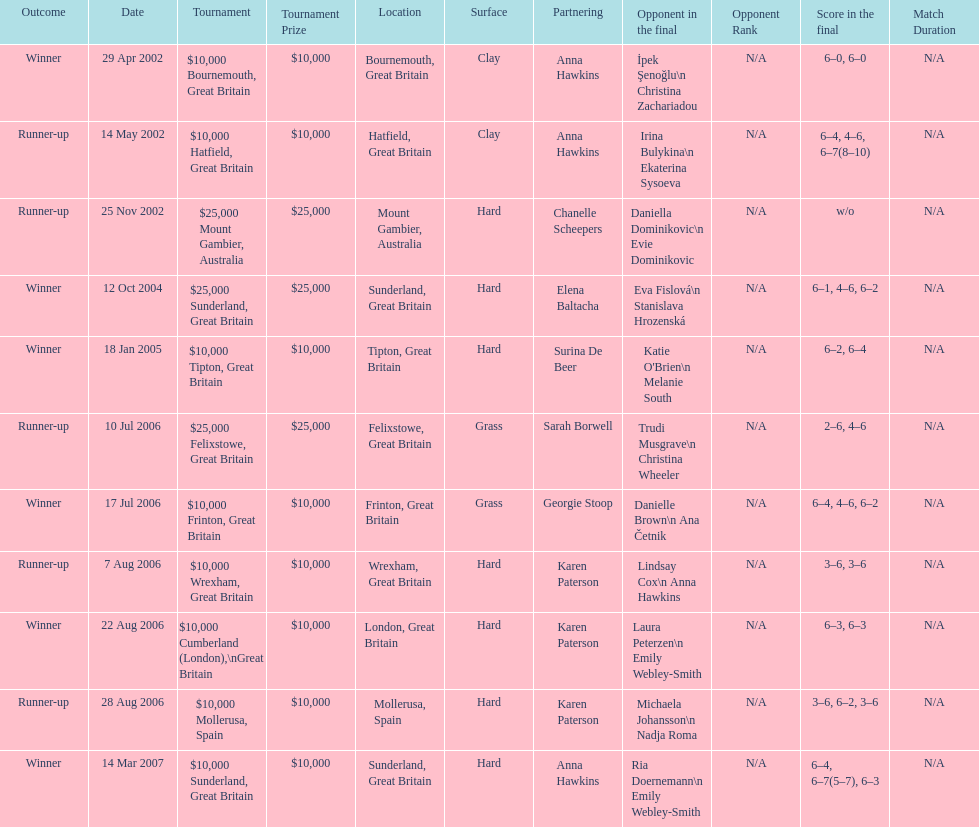Could you help me parse every detail presented in this table? {'header': ['Outcome', 'Date', 'Tournament', 'Tournament Prize', 'Location', 'Surface', 'Partnering', 'Opponent in the final', 'Opponent Rank', 'Score in the final', 'Match Duration'], 'rows': [['Winner', '29 Apr 2002', '$10,000 Bournemouth, Great Britain', '$10,000', 'Bournemouth, Great Britain', 'Clay', 'Anna Hawkins', 'İpek Şenoğlu\\n Christina Zachariadou', 'N/A', '6–0, 6–0', 'N/A'], ['Runner-up', '14 May 2002', '$10,000 Hatfield, Great Britain', '$10,000', 'Hatfield, Great Britain', 'Clay', 'Anna Hawkins', 'Irina Bulykina\\n Ekaterina Sysoeva', 'N/A', '6–4, 4–6, 6–7(8–10)', 'N/A'], ['Runner-up', '25 Nov 2002', '$25,000 Mount Gambier, Australia', '$25,000', 'Mount Gambier, Australia', 'Hard', 'Chanelle Scheepers', 'Daniella Dominikovic\\n Evie Dominikovic', 'N/A', 'w/o', 'N/A'], ['Winner', '12 Oct 2004', '$25,000 Sunderland, Great Britain', '$25,000', 'Sunderland, Great Britain', 'Hard', 'Elena Baltacha', 'Eva Fislová\\n Stanislava Hrozenská', 'N/A', '6–1, 4–6, 6–2', 'N/A'], ['Winner', '18 Jan 2005', '$10,000 Tipton, Great Britain', '$10,000', 'Tipton, Great Britain', 'Hard', 'Surina De Beer', "Katie O'Brien\\n Melanie South", 'N/A', '6–2, 6–4', 'N/A'], ['Runner-up', '10 Jul 2006', '$25,000 Felixstowe, Great Britain', '$25,000', 'Felixstowe, Great Britain', 'Grass', 'Sarah Borwell', 'Trudi Musgrave\\n Christina Wheeler', 'N/A', '2–6, 4–6', 'N/A'], ['Winner', '17 Jul 2006', '$10,000 Frinton, Great Britain', '$10,000', 'Frinton, Great Britain', 'Grass', 'Georgie Stoop', 'Danielle Brown\\n Ana Četnik', 'N/A', '6–4, 4–6, 6–2', 'N/A'], ['Runner-up', '7 Aug 2006', '$10,000 Wrexham, Great Britain', '$10,000', 'Wrexham, Great Britain', 'Hard', 'Karen Paterson', 'Lindsay Cox\\n Anna Hawkins', 'N/A', '3–6, 3–6', 'N/A'], ['Winner', '22 Aug 2006', '$10,000 Cumberland (London),\\nGreat Britain', '$10,000', 'London, Great Britain', 'Hard', 'Karen Paterson', 'Laura Peterzen\\n Emily Webley-Smith', 'N/A', '6–3, 6–3', 'N/A'], ['Runner-up', '28 Aug 2006', '$10,000 Mollerusa, Spain', '$10,000', 'Mollerusa, Spain', 'Hard', 'Karen Paterson', 'Michaela Johansson\\n Nadja Roma', 'N/A', '3–6, 6–2, 3–6', 'N/A'], ['Winner', '14 Mar 2007', '$10,000 Sunderland, Great Britain', '$10,000', 'Sunderland, Great Britain', 'Hard', 'Anna Hawkins', 'Ria Doernemann\\n Emily Webley-Smith', 'N/A', '6–4, 6–7(5–7), 6–3', 'N/A']]} How many were played on a hard surface? 7. 